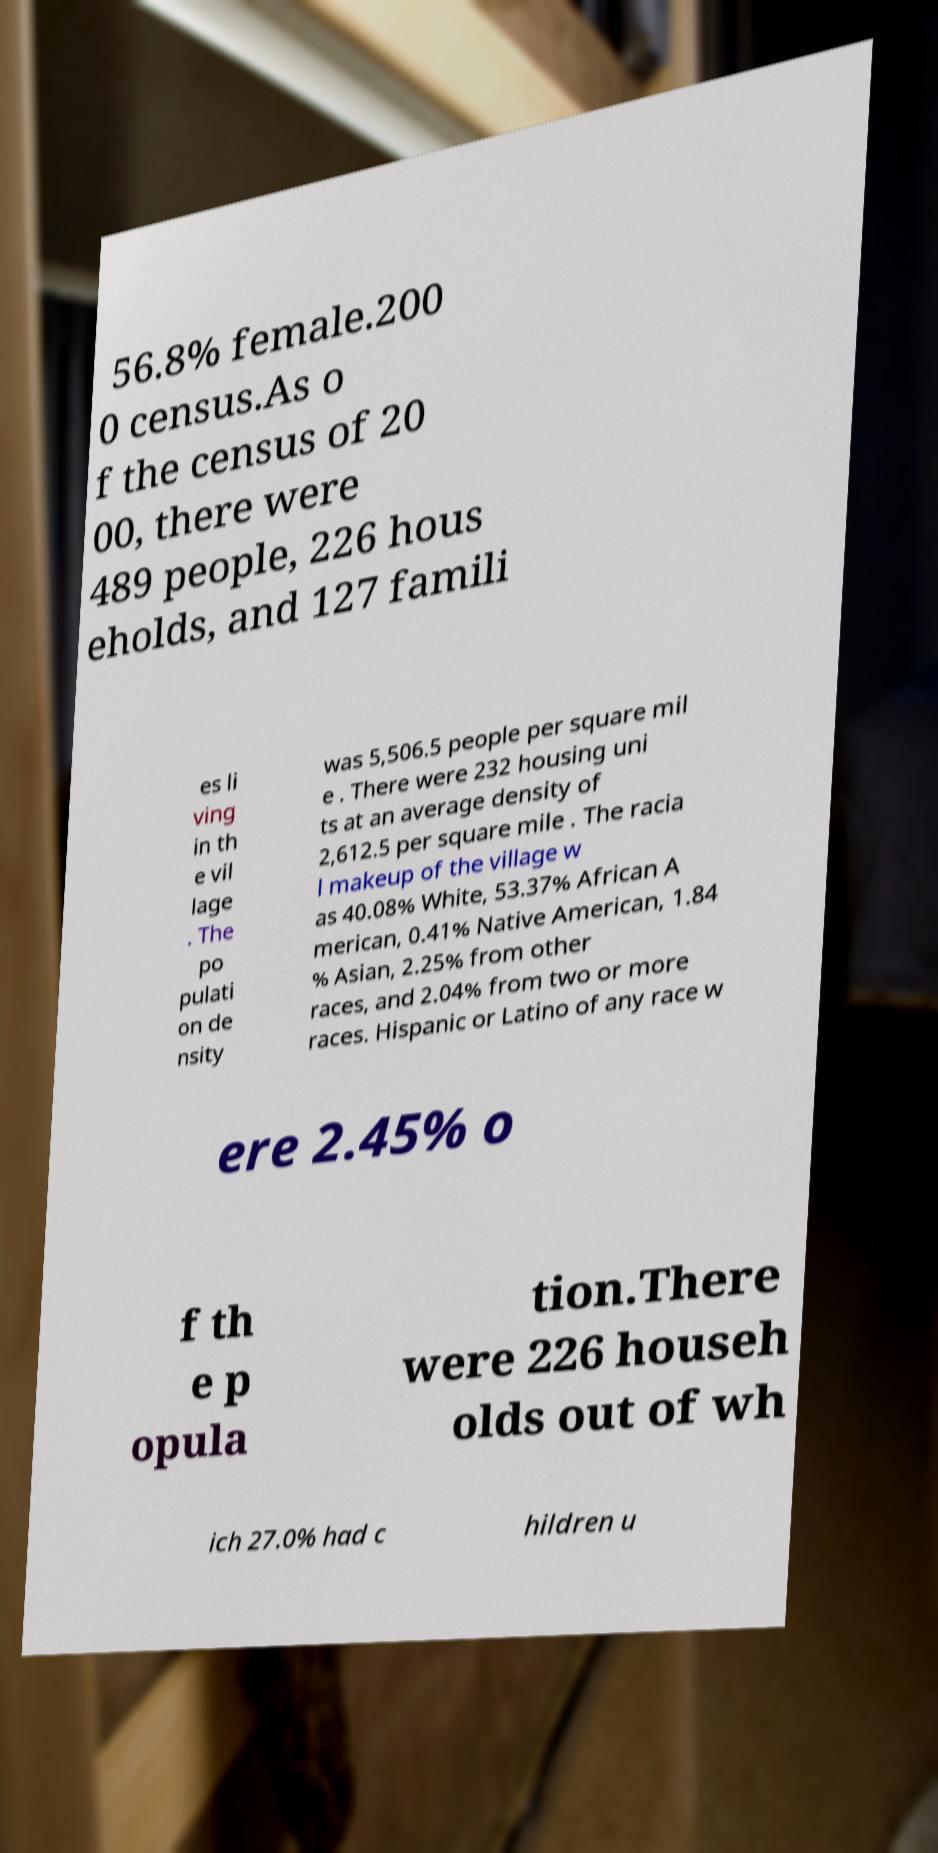For documentation purposes, I need the text within this image transcribed. Could you provide that? 56.8% female.200 0 census.As o f the census of 20 00, there were 489 people, 226 hous eholds, and 127 famili es li ving in th e vil lage . The po pulati on de nsity was 5,506.5 people per square mil e . There were 232 housing uni ts at an average density of 2,612.5 per square mile . The racia l makeup of the village w as 40.08% White, 53.37% African A merican, 0.41% Native American, 1.84 % Asian, 2.25% from other races, and 2.04% from two or more races. Hispanic or Latino of any race w ere 2.45% o f th e p opula tion.There were 226 househ olds out of wh ich 27.0% had c hildren u 